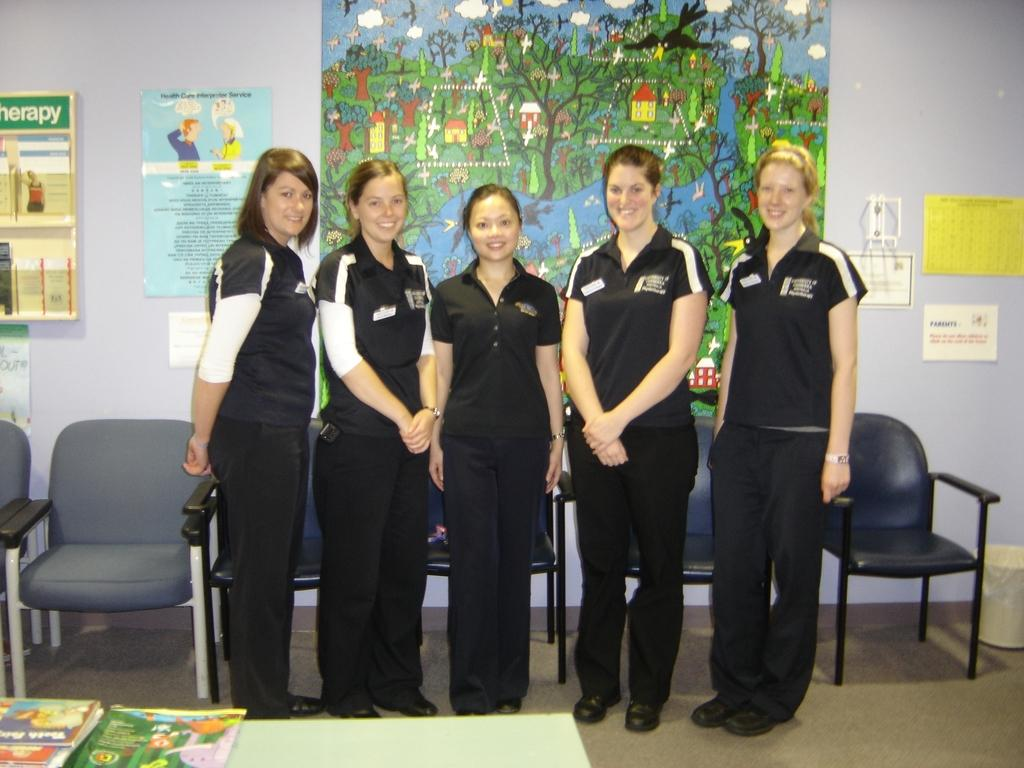How many women are present in the image? There are five women in the image. What are the women doing in the image? The women are standing and laughing. What objects are in front of the women? There are books in front of the women. What can be seen in the background of the image? There are chairs and a paper attached to a wall in the background. What type of frame is around the women in the image? There is no frame around the women in the image; they are standing in a room or space. 